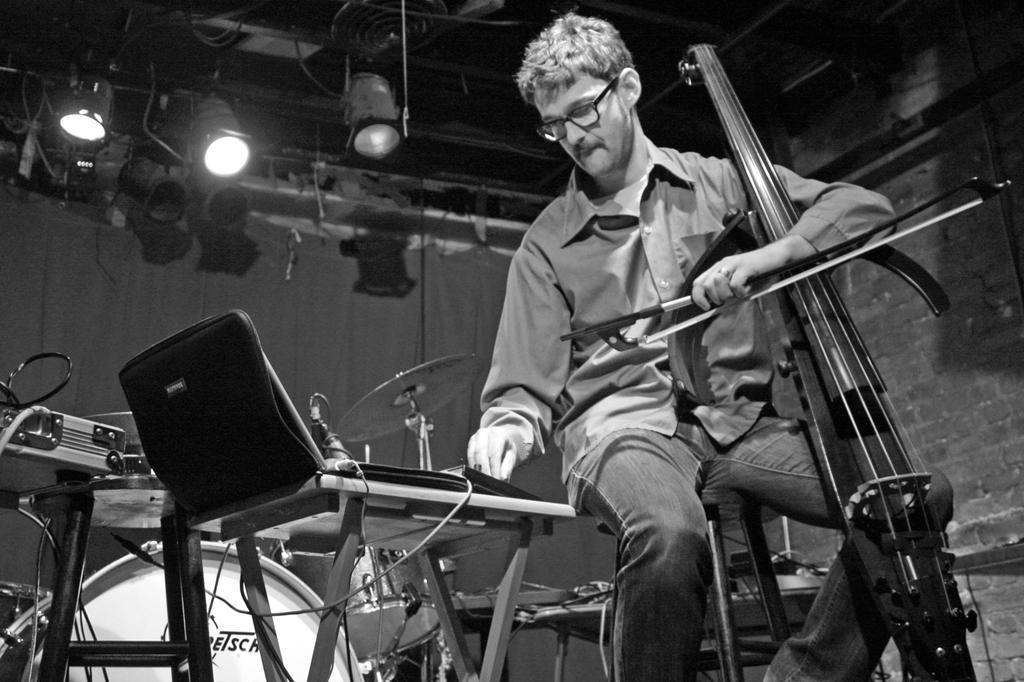Can you describe this image briefly? Here we can see a person sitting on a chair with a violin in his hand and in front of him we can see a laptop and he is adjusting some musical notes and there are drums and other musical instruments present and there are lights at the top 